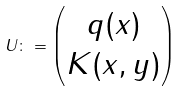<formula> <loc_0><loc_0><loc_500><loc_500>U \colon = \begin{pmatrix} q ( x ) \\ K ( x , y ) \end{pmatrix}</formula> 